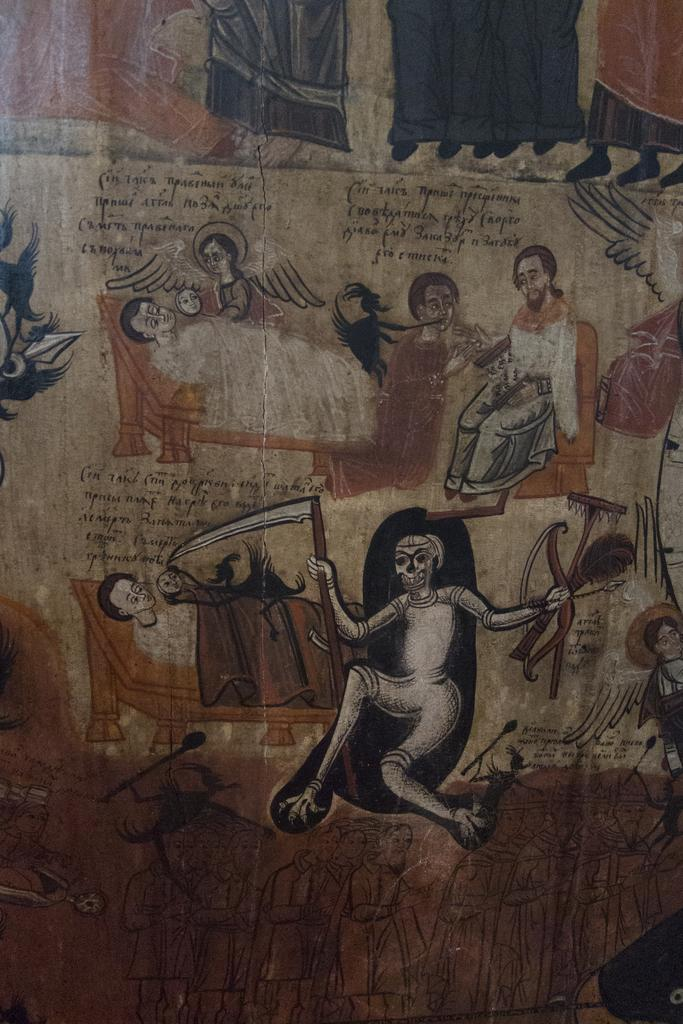How many people are in the image? There are people in the image. What are the positions of the people in the image? One person is lying down, and another person is sitting on a chair. What else can be seen in the image besides the people? There is a painting with writing on it in the image. What type of pot is being used by the laborer in the image? There is no laborer or pot present in the image. How does the wind affect the people in the image? The image does not show any wind or its effects on the people. 